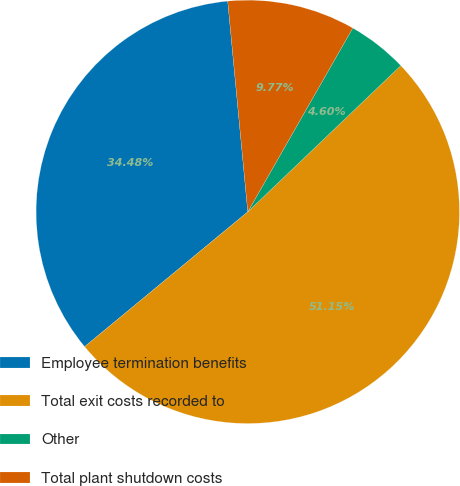Convert chart. <chart><loc_0><loc_0><loc_500><loc_500><pie_chart><fcel>Employee termination benefits<fcel>Total exit costs recorded to<fcel>Other<fcel>Total plant shutdown costs<nl><fcel>34.48%<fcel>51.15%<fcel>4.6%<fcel>9.77%<nl></chart> 